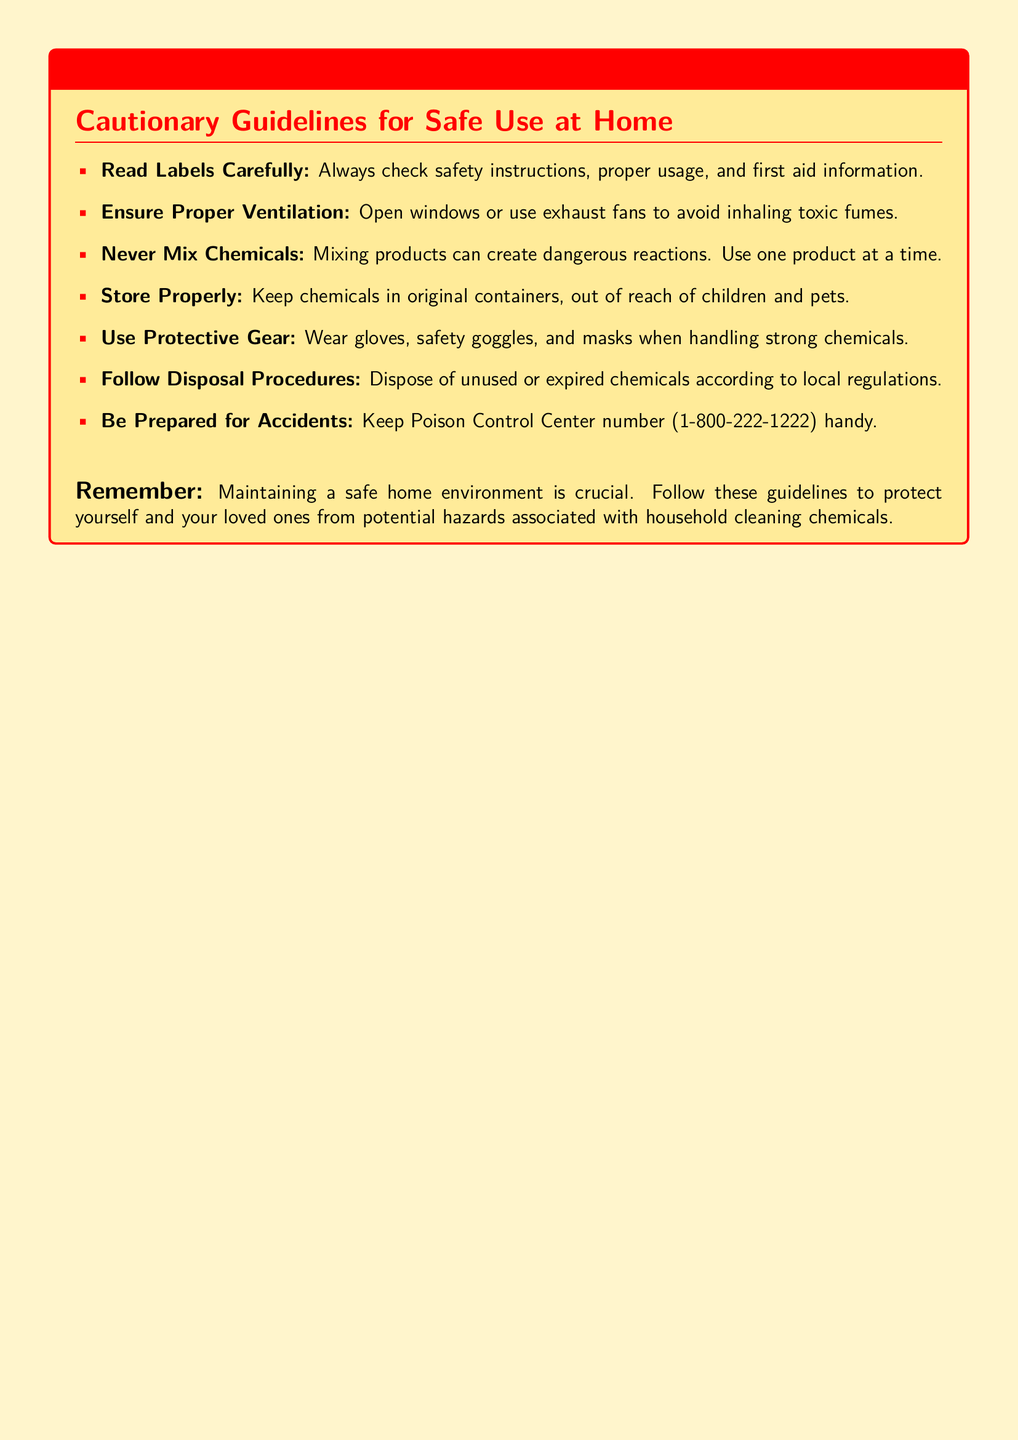What is the main purpose of this document? The main purpose of the document is to provide guidelines for the safe use of household cleaning chemicals at home.
Answer: Cautionary Guidelines for Safe Use at Home What should you check carefully before using cleaning chemicals? You should check safety instructions, proper usage, and first aid information on the labels.
Answer: Labels What is one of the key precautions regarding chemical storage? Chemicals should be kept in original containers and out of reach of children and pets.
Answer: Store Properly What should you wear when handling strong chemicals? You should wear gloves, safety goggles, and masks.
Answer: Protective Gear What number should you keep handy for emergencies? The number for Poison Control Center is 1-800-222-1222.
Answer: 1-800-222-1222 Why is it important to ensure proper ventilation? Proper ventilation helps avoid inhaling toxic fumes when using cleaning chemicals.
Answer: Inhaling toxic fumes What should you never do with cleaning products? You should never mix chemicals as it can create dangerous reactions.
Answer: Never Mix Chemicals 